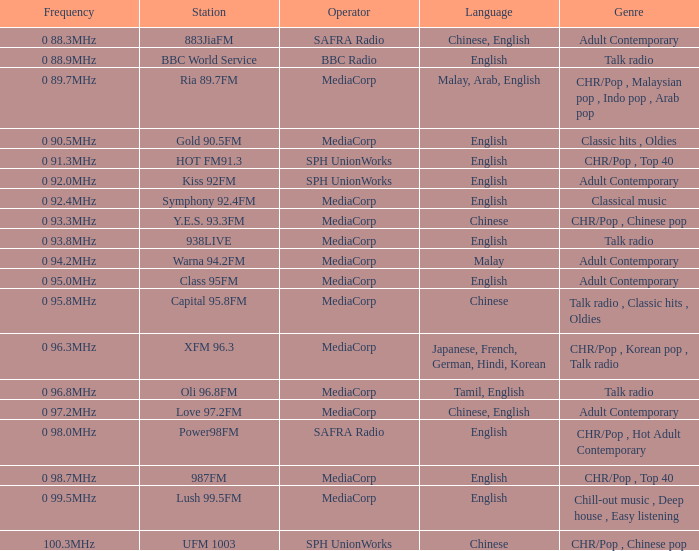What is the genre of the BBC World Service? Talk radio. 